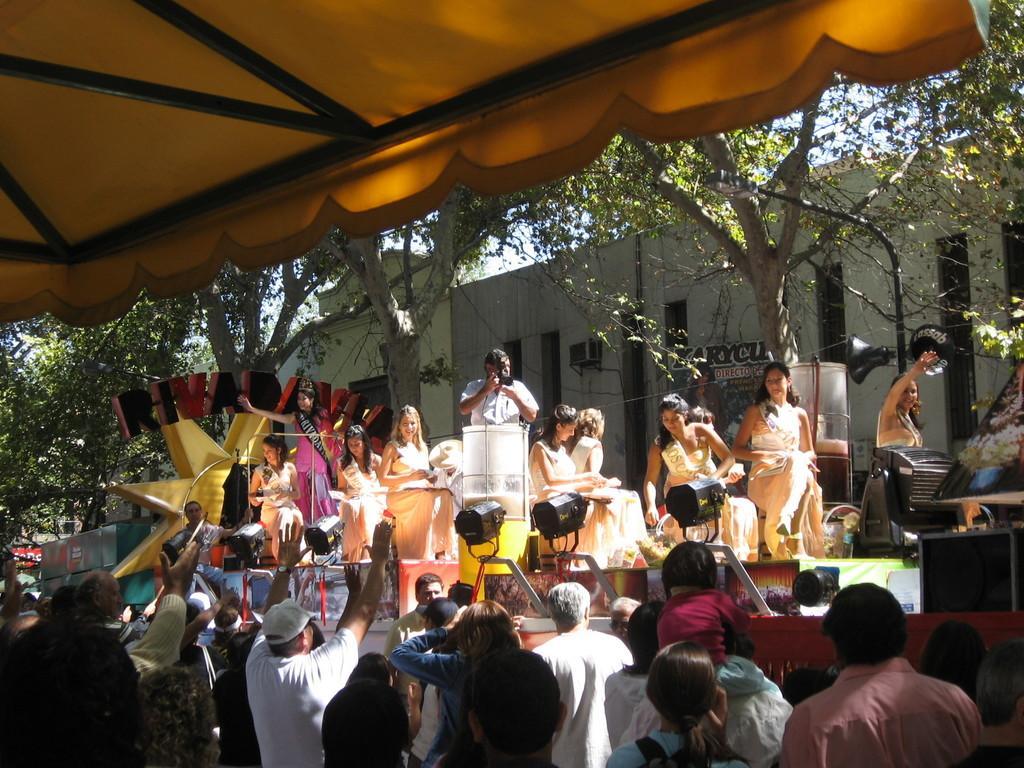Could you give a brief overview of what you see in this image? In this picture we can see tent, rods, building, trees, people, focusing lights, speakers, light pole, hoarding, pictures and things. Middle of the picture a person is standing and holding a camera. 